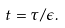<formula> <loc_0><loc_0><loc_500><loc_500>t = \tau / \epsilon .</formula> 